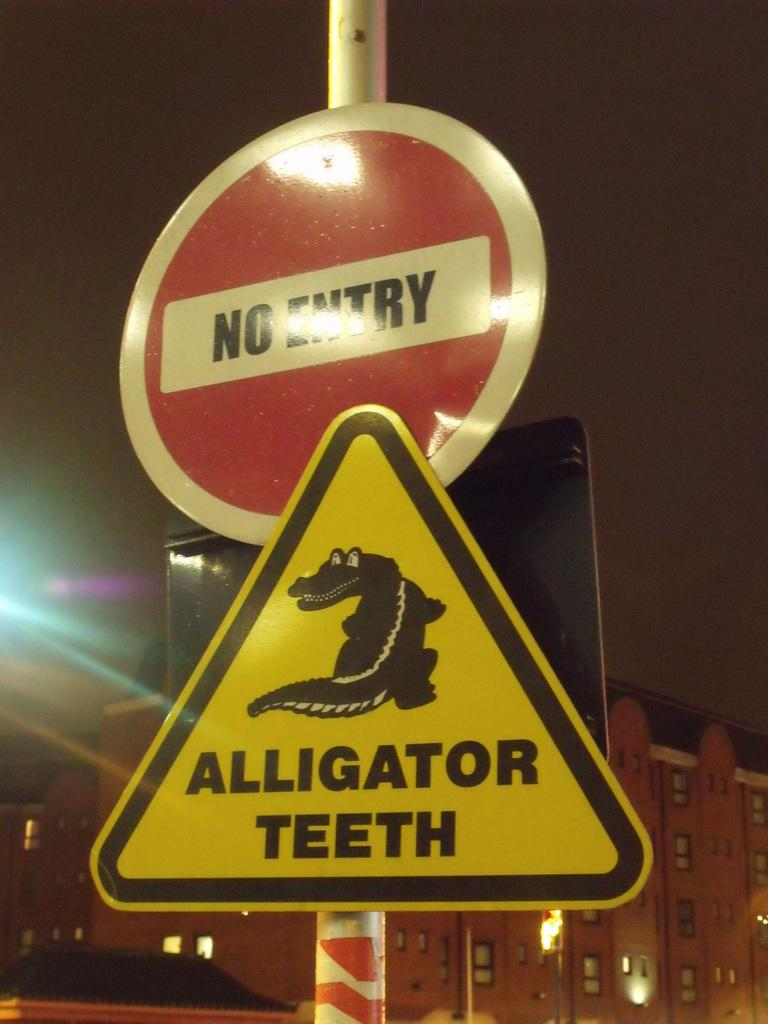Provide a one-sentence caption for the provided image. A yellow yield sign with an alligator picture on it is below a red and white sign that says No Entry. 